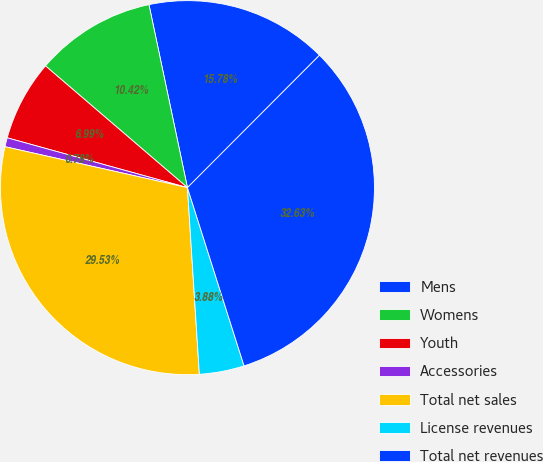<chart> <loc_0><loc_0><loc_500><loc_500><pie_chart><fcel>Mens<fcel>Womens<fcel>Youth<fcel>Accessories<fcel>Total net sales<fcel>License revenues<fcel>Total net revenues<nl><fcel>15.78%<fcel>10.42%<fcel>6.99%<fcel>0.78%<fcel>29.53%<fcel>3.88%<fcel>32.63%<nl></chart> 